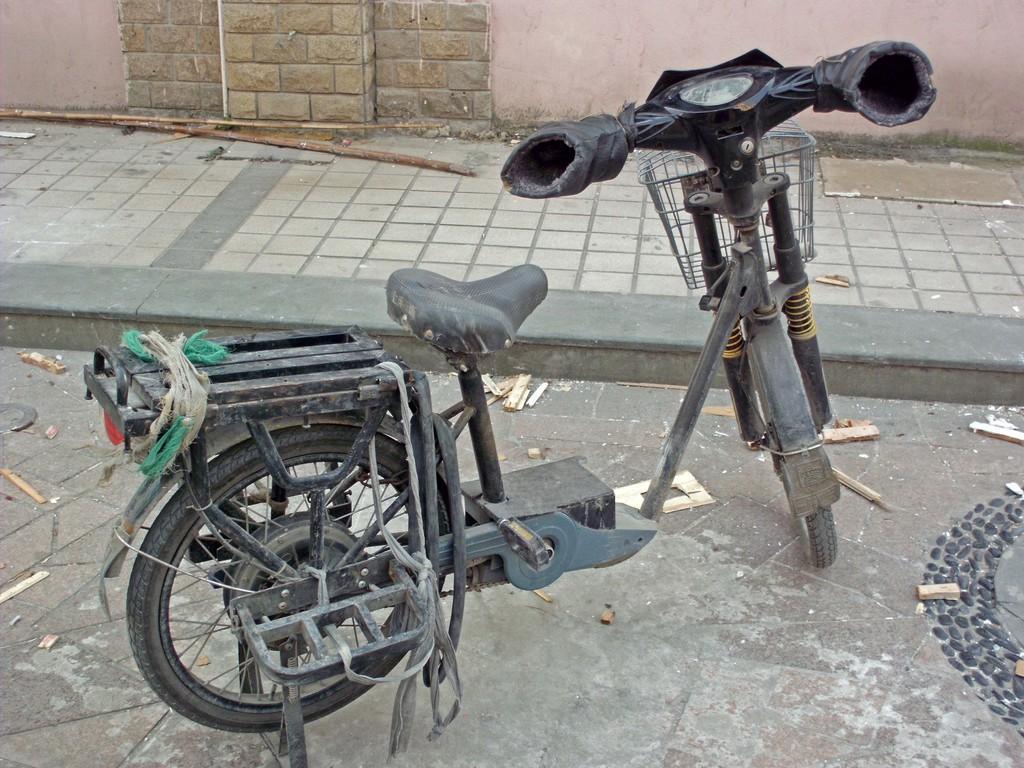How would you summarize this image in a sentence or two? In this picture, we see a moped. At the bottom, we see the road and the wooden twigs. Beside that, we see a footpath on which the wooden sticks are placed. In the background, we see a wall. 